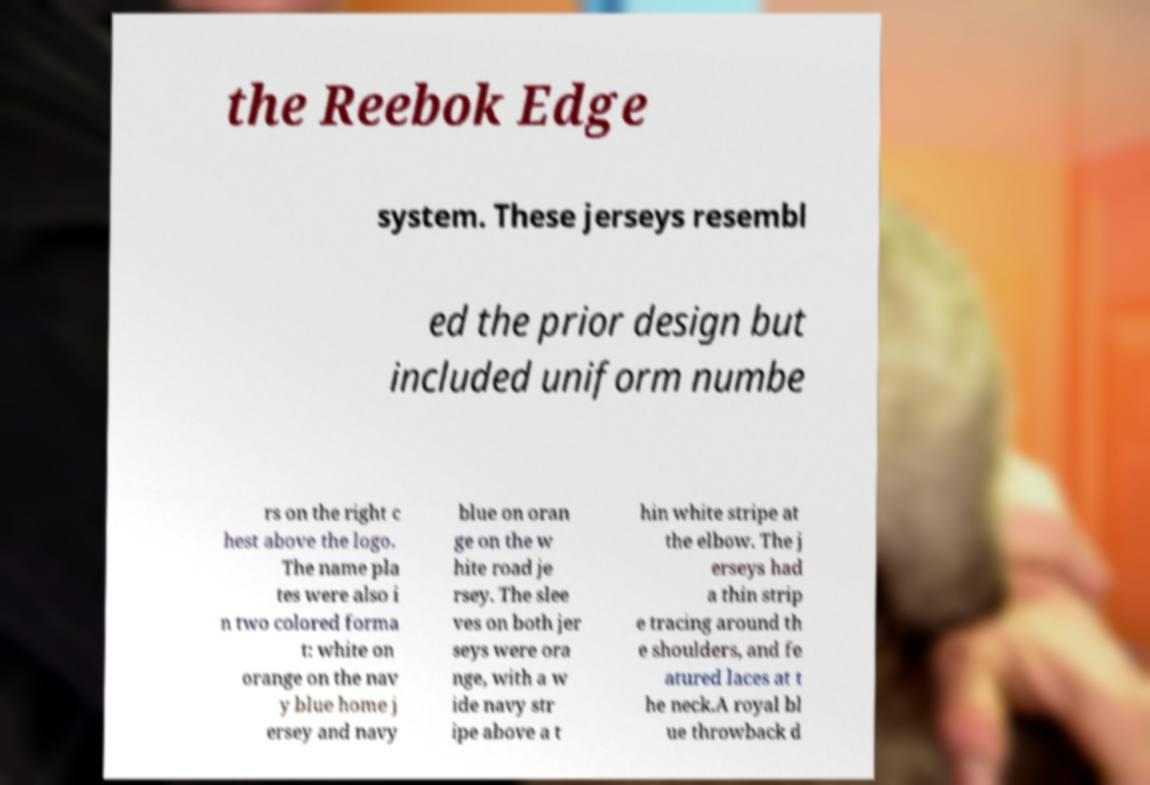Can you read and provide the text displayed in the image?This photo seems to have some interesting text. Can you extract and type it out for me? the Reebok Edge system. These jerseys resembl ed the prior design but included uniform numbe rs on the right c hest above the logo. The name pla tes were also i n two colored forma t: white on orange on the nav y blue home j ersey and navy blue on oran ge on the w hite road je rsey. The slee ves on both jer seys were ora nge, with a w ide navy str ipe above a t hin white stripe at the elbow. The j erseys had a thin strip e tracing around th e shoulders, and fe atured laces at t he neck.A royal bl ue throwback d 